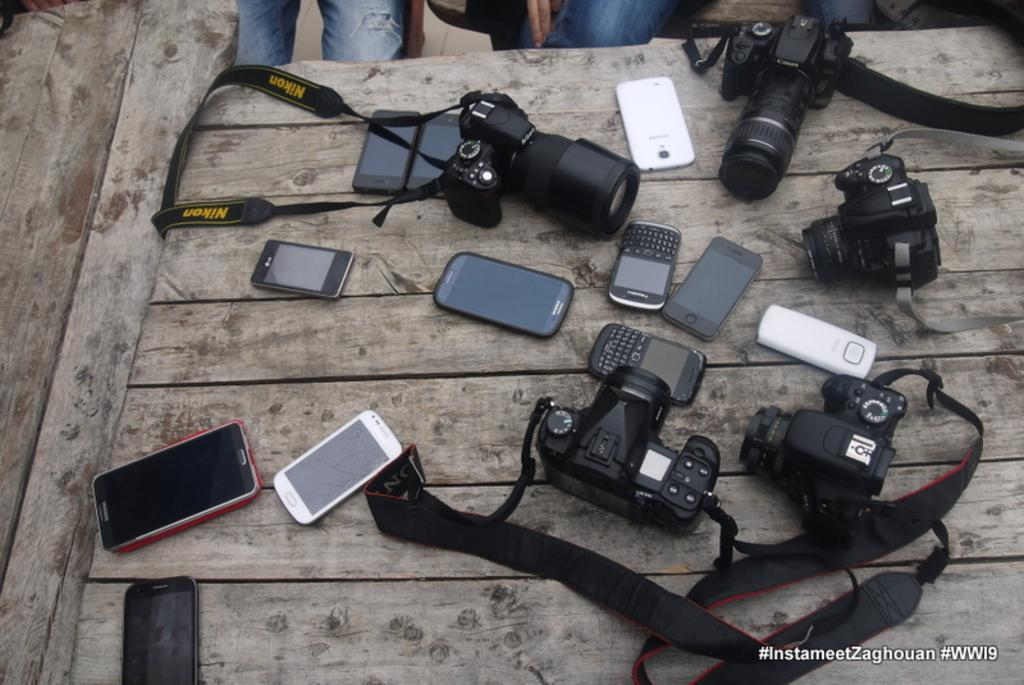What type of surface is visible in the image? There is a wooden surface in the image. What objects are placed on the wooden surface? There are mobiles and cameras on the wooden surface. Can you describe the presence of people in the image? There are legs of persons visible in the image. Where is the text or writing located in the image? The text or writing is in the right bottom corner of the image. What type of furniture is being used to sense the nerve in the image? There is no furniture, sense, or nerve present in the image. 